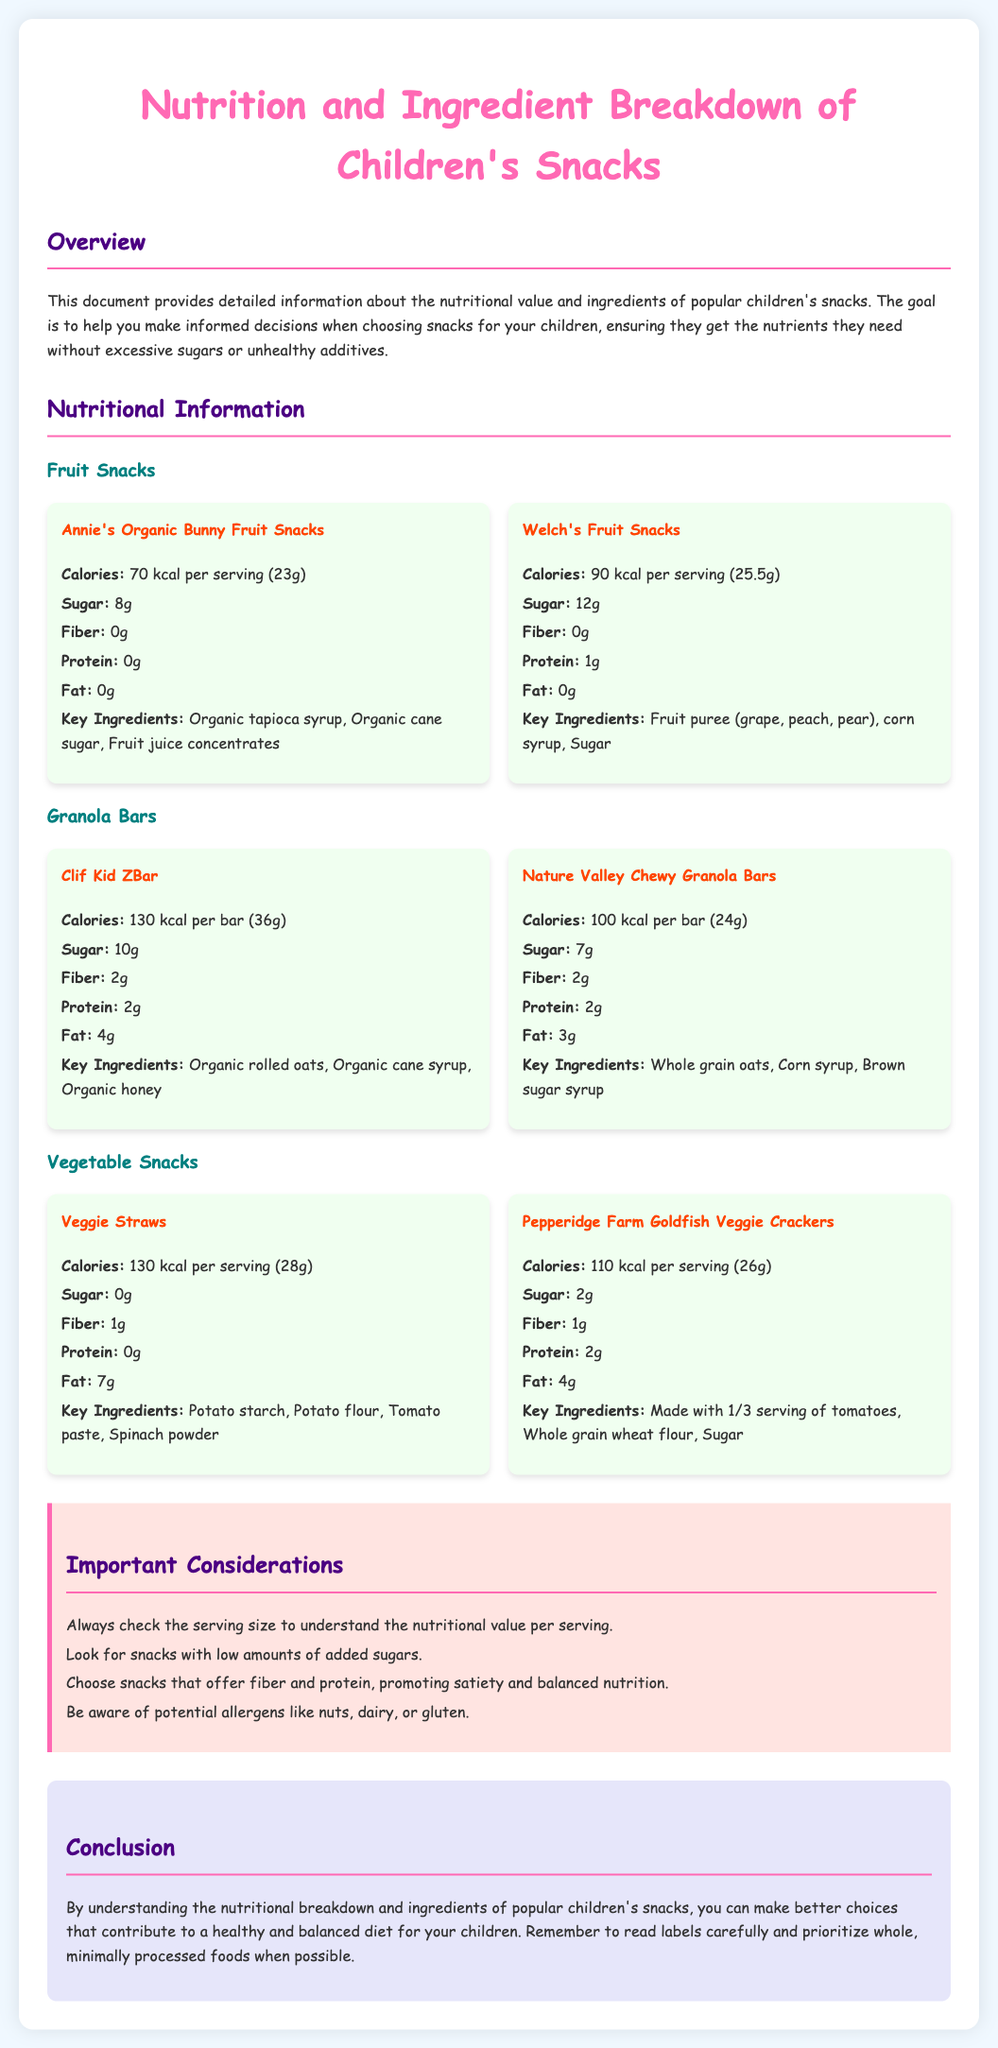What are the key ingredients in Annie's Organic Bunny Fruit Snacks? The key ingredients listed for this snack include organic tapioca syrup, organic cane sugar, and fruit juice concentrates.
Answer: Organic tapioca syrup, organic cane sugar, fruit juice concentrates How much sugar is in Welch's Fruit Snacks? The document specifies that Welch's Fruit Snacks contain 12 grams of sugar per serving.
Answer: 12g How many calories are in a serving of Clif Kid ZBar? The nutritional information indicates that Clif Kid ZBar has 130 calories per bar.
Answer: 130 kcal Which snack has the highest fat content? By comparing the fat content in the snacks, Veggie Straws have 7 grams of fat, which is the highest among the listed snacks.
Answer: Veggie Straws What is the primary ingredient in Pepperidge Farm Goldfish Veggie Crackers? The document states that these crackers are made with 1/3 serving of tomatoes and whole grain wheat flour, identifying them as the primary ingredient.
Answer: Whole grain wheat flour Which type of snack usually contains more added sugars, fruit snacks or granola bars? The document shows that both fruit snacks generally have higher sugar contents compared to granola bars, indicating that fruit snacks typically contain more added sugars.
Answer: Fruit snacks What is one important consideration when choosing children’s snacks? The document recommends looking for snacks with low amounts of added sugars as an important consideration when selecting snacks for children.
Answer: Low amounts of added sugars What is the total fiber content in Nature Valley Chewy Granola Bars? Nature Valley Chewy Granola Bars contain 2 grams of fiber per bar, based on the nutritional breakdown provided.
Answer: 2g How many grams of protein are in Veggie Straws? According to the information provided, Veggie Straws contain 0 grams of protein per serving.
Answer: 0g 